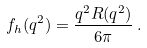Convert formula to latex. <formula><loc_0><loc_0><loc_500><loc_500>f _ { h } ( q ^ { 2 } ) = \frac { q ^ { 2 } R ( q ^ { 2 } ) } { 6 \pi } \, .</formula> 